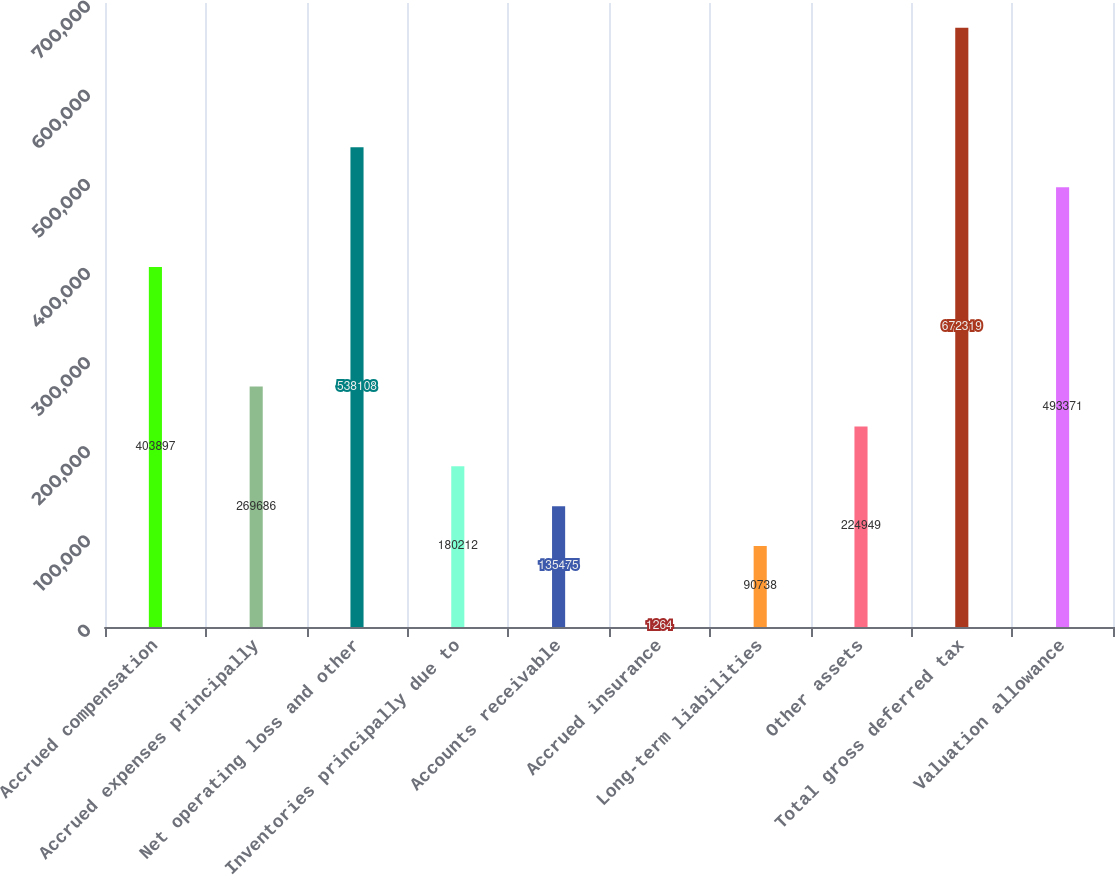<chart> <loc_0><loc_0><loc_500><loc_500><bar_chart><fcel>Accrued compensation<fcel>Accrued expenses principally<fcel>Net operating loss and other<fcel>Inventories principally due to<fcel>Accounts receivable<fcel>Accrued insurance<fcel>Long-term liabilities<fcel>Other assets<fcel>Total gross deferred tax<fcel>Valuation allowance<nl><fcel>403897<fcel>269686<fcel>538108<fcel>180212<fcel>135475<fcel>1264<fcel>90738<fcel>224949<fcel>672319<fcel>493371<nl></chart> 